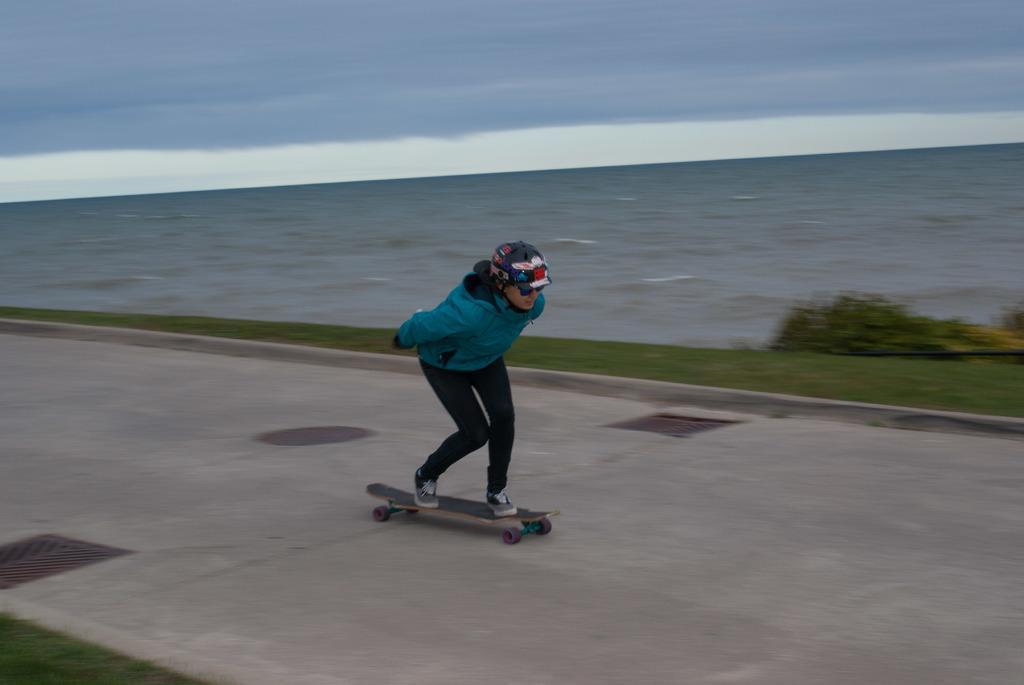Describe this image in one or two sentences. In the center of the image we can see a lady is standing on a skating board and wearing a coat, goggles, cap. In the background of the image we can see the water, plants, grass, road. At the top of the image we can see the clouds are present in the sky. 